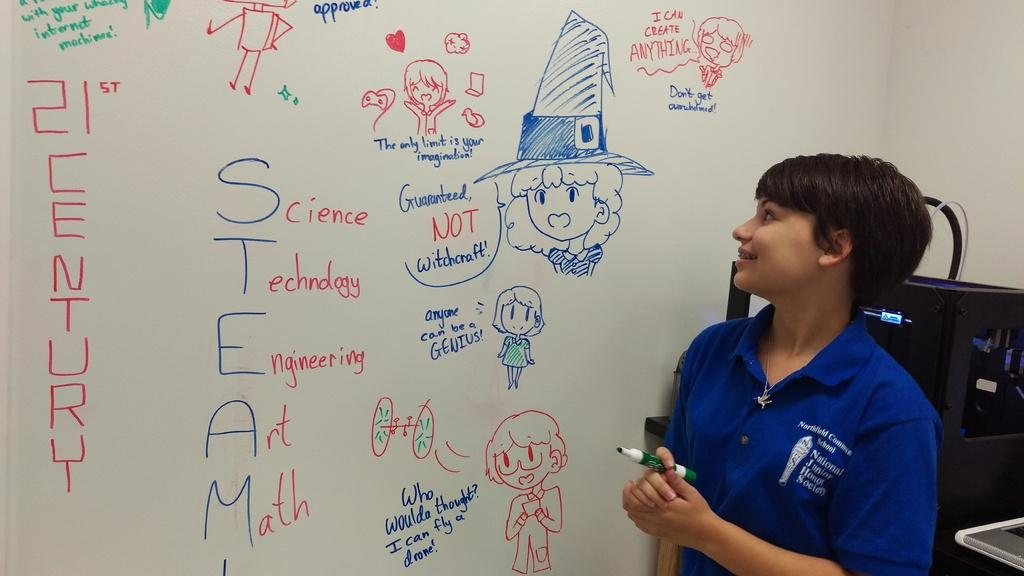<image>
Create a compact narrative representing the image presented. A teacher stands next to the board where cartoon pictures surround the word STEAM and each letter has a word next to it. 